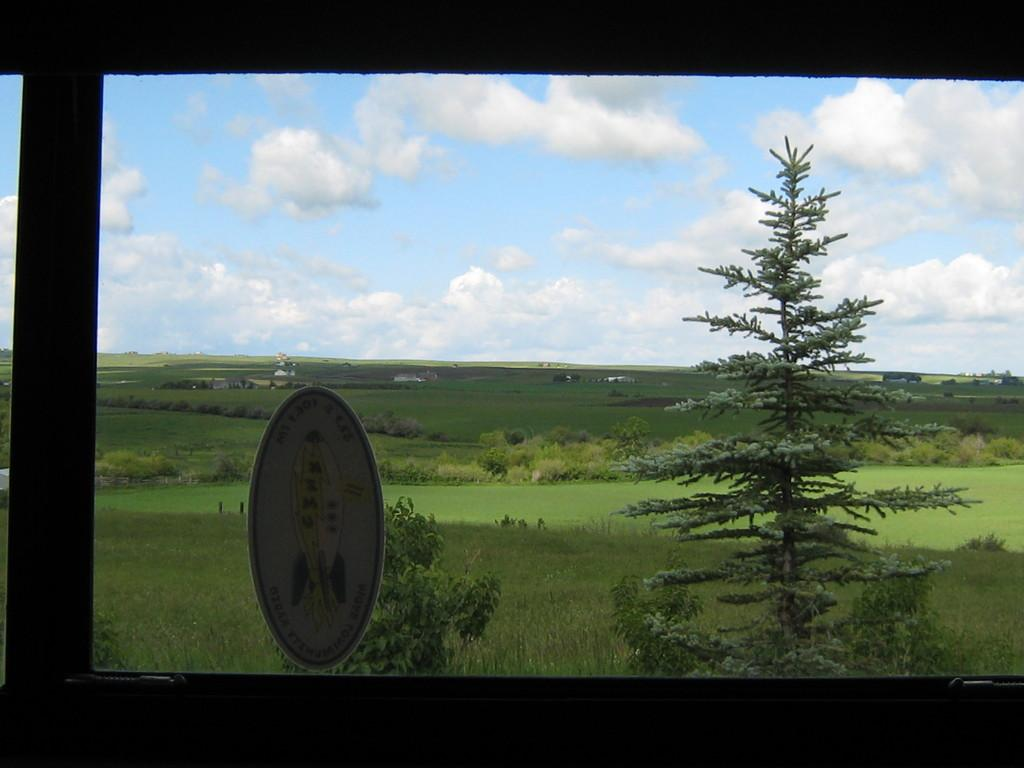What is the main subject of the image? The image is a zoomed-in view of a window. What can be seen on the window itself? There is a logo on the window. What type of natural environment is visible behind the window? Trees, grass, and the sky with clouds are visible behind the window. What type of holiday is being celebrated in the image? There is no indication of a holiday being celebrated in the image, as it is a zoomed-in view of a window with a logo and a natural background. What type of marble can be seen on the window sill? There is no marble visible in the image; it is a window with a logo and a natural background. 